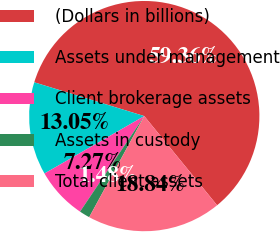<chart> <loc_0><loc_0><loc_500><loc_500><pie_chart><fcel>(Dollars in billions)<fcel>Assets under management<fcel>Client brokerage assets<fcel>Assets in custody<fcel>Total client assets<nl><fcel>59.36%<fcel>13.05%<fcel>7.27%<fcel>1.48%<fcel>18.84%<nl></chart> 